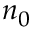Convert formula to latex. <formula><loc_0><loc_0><loc_500><loc_500>n _ { 0 }</formula> 